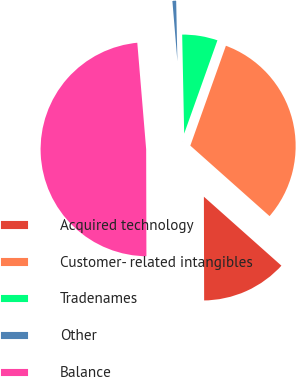<chart> <loc_0><loc_0><loc_500><loc_500><pie_chart><fcel>Acquired technology<fcel>Customer- related intangibles<fcel>Tradenames<fcel>Other<fcel>Balance<nl><fcel>13.39%<fcel>31.12%<fcel>5.77%<fcel>1.0%<fcel>48.71%<nl></chart> 